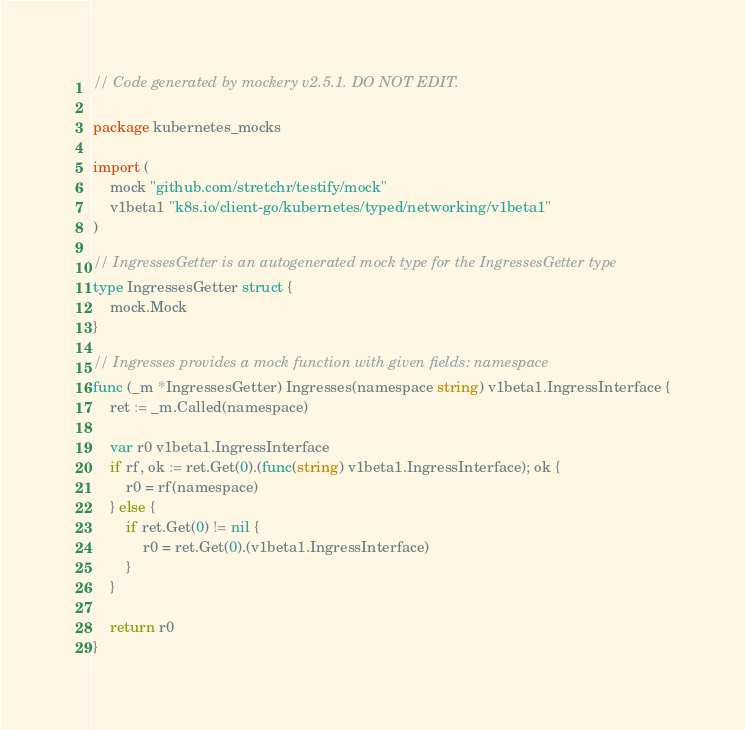Convert code to text. <code><loc_0><loc_0><loc_500><loc_500><_Go_>// Code generated by mockery v2.5.1. DO NOT EDIT.

package kubernetes_mocks

import (
	mock "github.com/stretchr/testify/mock"
	v1beta1 "k8s.io/client-go/kubernetes/typed/networking/v1beta1"
)

// IngressesGetter is an autogenerated mock type for the IngressesGetter type
type IngressesGetter struct {
	mock.Mock
}

// Ingresses provides a mock function with given fields: namespace
func (_m *IngressesGetter) Ingresses(namespace string) v1beta1.IngressInterface {
	ret := _m.Called(namespace)

	var r0 v1beta1.IngressInterface
	if rf, ok := ret.Get(0).(func(string) v1beta1.IngressInterface); ok {
		r0 = rf(namespace)
	} else {
		if ret.Get(0) != nil {
			r0 = ret.Get(0).(v1beta1.IngressInterface)
		}
	}

	return r0
}
</code> 